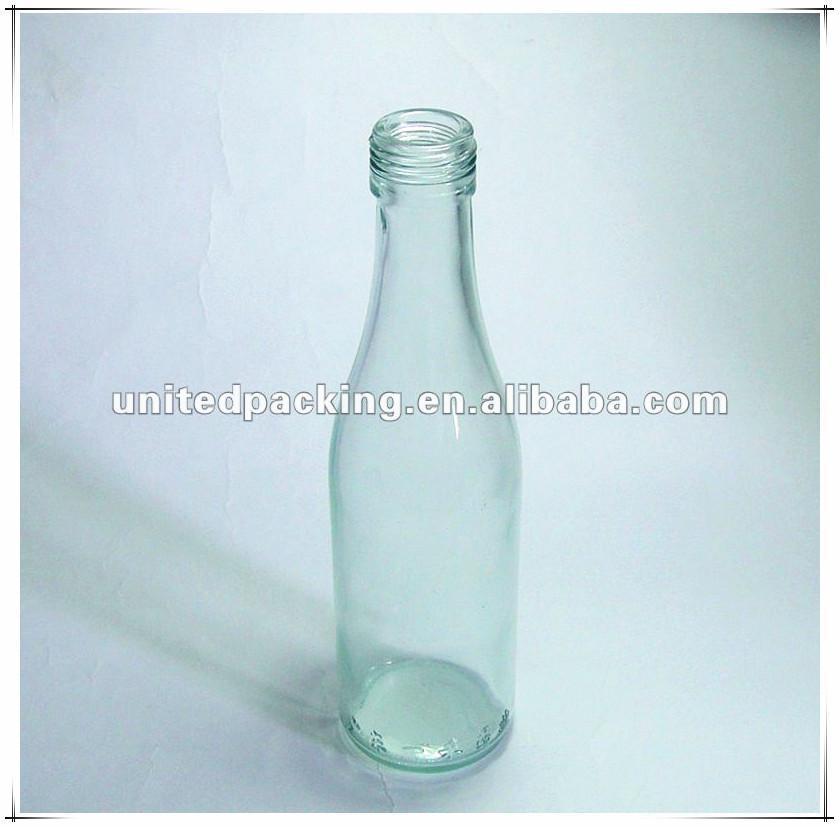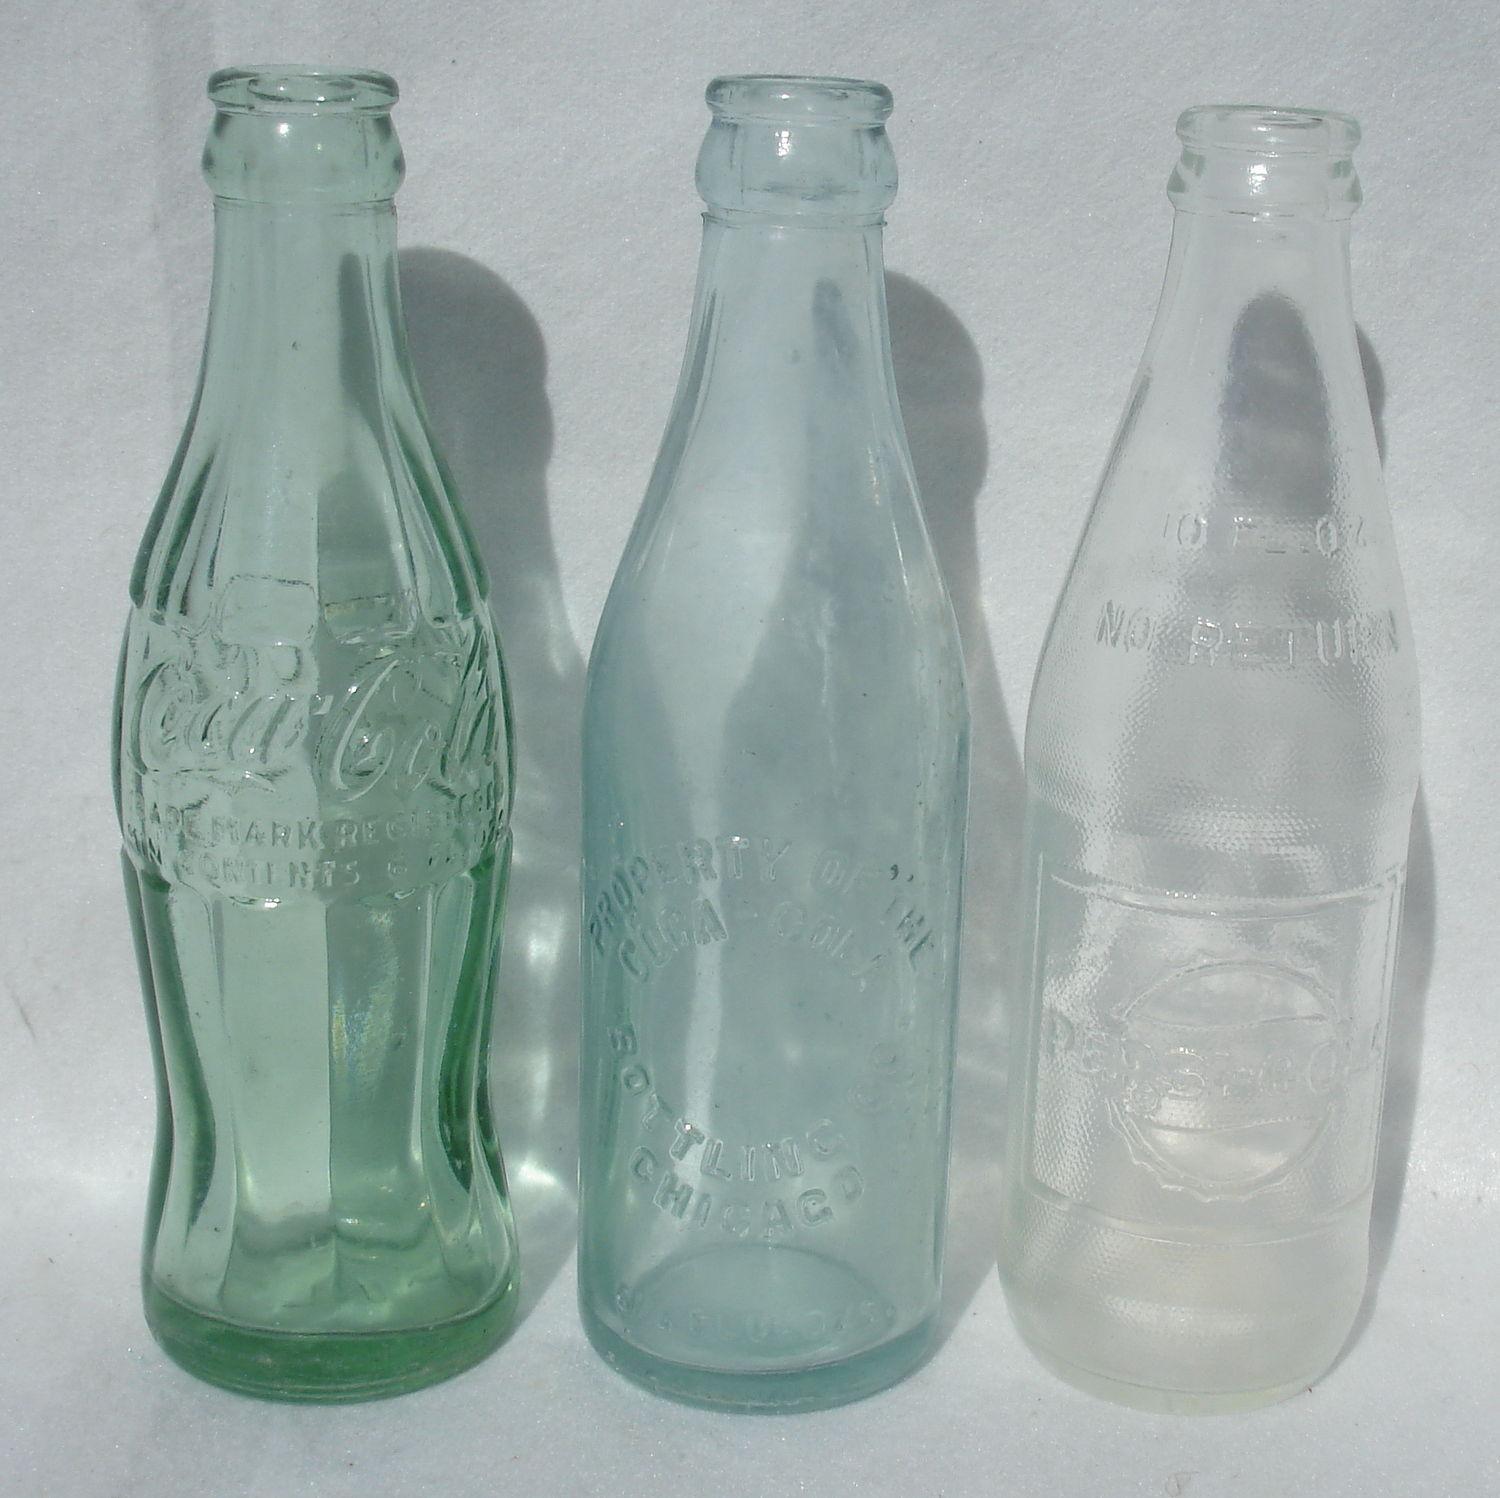The first image is the image on the left, the second image is the image on the right. Considering the images on both sides, is "The left image contains a single glass bottle with no label on its bottom half, and the right image contains at least three glass bottles with no labels." valid? Answer yes or no. Yes. The first image is the image on the left, the second image is the image on the right. Assess this claim about the two images: "There are two bottles". Correct or not? Answer yes or no. No. 